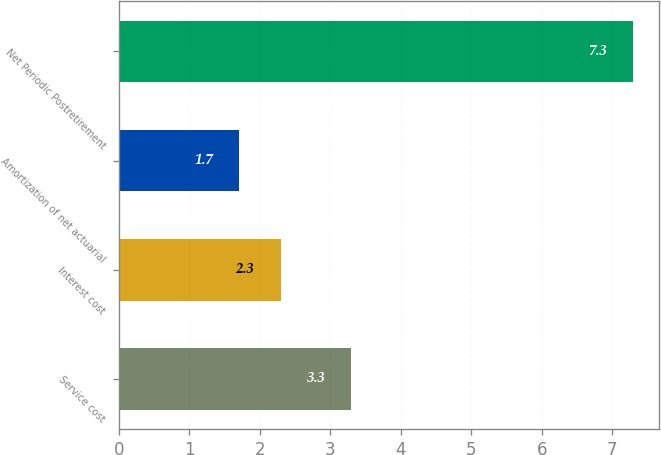Convert chart to OTSL. <chart><loc_0><loc_0><loc_500><loc_500><bar_chart><fcel>Service cost<fcel>Interest cost<fcel>Amortization of net actuarial<fcel>Net Periodic Postretirement<nl><fcel>3.3<fcel>2.3<fcel>1.7<fcel>7.3<nl></chart> 